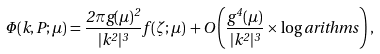<formula> <loc_0><loc_0><loc_500><loc_500>\Phi ( k , P ; \mu ) = \frac { 2 \pi g ( \mu ) ^ { 2 } } { | k ^ { 2 } | ^ { 3 } } f ( \zeta ; \mu ) \, + O \left ( \frac { g ^ { 4 } ( \mu ) } { | k ^ { 2 } | ^ { 3 } } \times \log a r i t h m s \right ) ,</formula> 